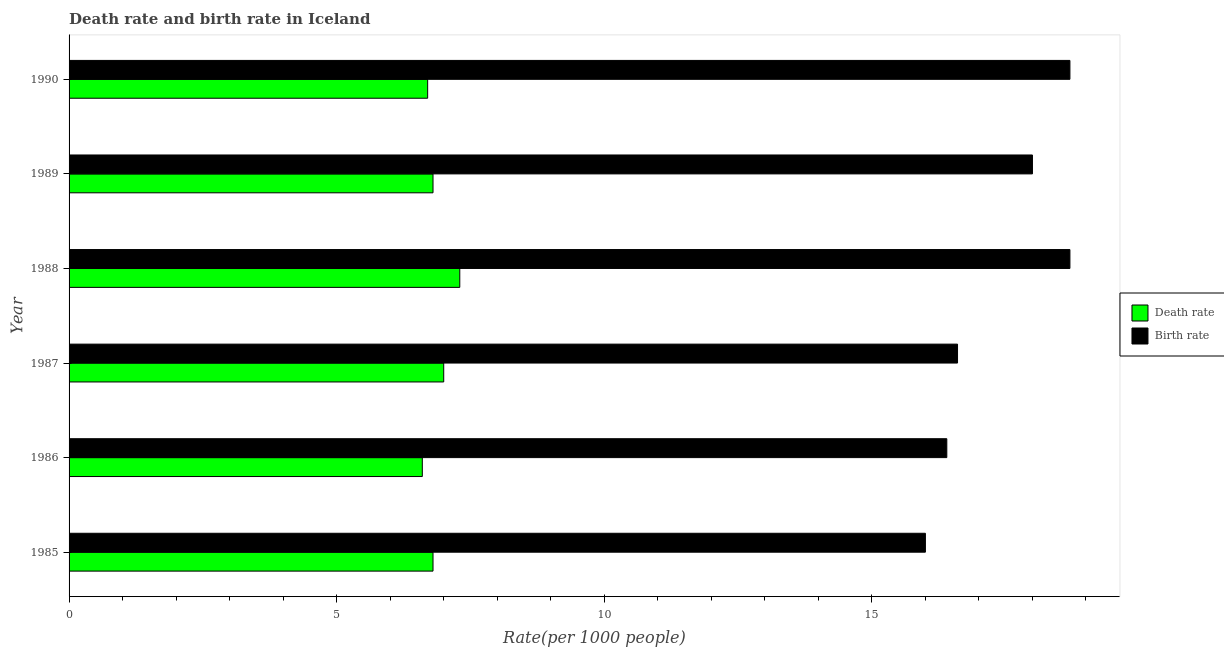How many different coloured bars are there?
Provide a short and direct response. 2. How many groups of bars are there?
Your response must be concise. 6. Are the number of bars per tick equal to the number of legend labels?
Provide a succinct answer. Yes. Are the number of bars on each tick of the Y-axis equal?
Offer a very short reply. Yes. How many bars are there on the 5th tick from the bottom?
Give a very brief answer. 2. What is the label of the 1st group of bars from the top?
Offer a very short reply. 1990. In how many cases, is the number of bars for a given year not equal to the number of legend labels?
Ensure brevity in your answer.  0. What is the death rate in 1987?
Provide a short and direct response. 7. In which year was the death rate maximum?
Offer a terse response. 1988. What is the total birth rate in the graph?
Your response must be concise. 104.4. What is the difference between the birth rate in 1989 and that in 1990?
Provide a succinct answer. -0.7. What is the average birth rate per year?
Give a very brief answer. 17.4. In how many years, is the birth rate greater than 4 ?
Make the answer very short. 6. What is the ratio of the death rate in 1985 to that in 1989?
Your answer should be very brief. 1. Is the death rate in 1987 less than that in 1989?
Give a very brief answer. No. What is the difference between the highest and the lowest birth rate?
Provide a succinct answer. 2.7. In how many years, is the birth rate greater than the average birth rate taken over all years?
Offer a very short reply. 3. What does the 1st bar from the top in 1985 represents?
Make the answer very short. Birth rate. What does the 1st bar from the bottom in 1986 represents?
Give a very brief answer. Death rate. How many bars are there?
Keep it short and to the point. 12. Are all the bars in the graph horizontal?
Offer a terse response. Yes. What is the difference between two consecutive major ticks on the X-axis?
Keep it short and to the point. 5. Does the graph contain any zero values?
Offer a very short reply. No. Does the graph contain grids?
Make the answer very short. No. Where does the legend appear in the graph?
Make the answer very short. Center right. How many legend labels are there?
Offer a terse response. 2. How are the legend labels stacked?
Provide a short and direct response. Vertical. What is the title of the graph?
Provide a short and direct response. Death rate and birth rate in Iceland. What is the label or title of the X-axis?
Your response must be concise. Rate(per 1000 people). What is the label or title of the Y-axis?
Provide a short and direct response. Year. What is the Rate(per 1000 people) of Death rate in 1985?
Give a very brief answer. 6.8. What is the Rate(per 1000 people) of Death rate in 1986?
Your answer should be very brief. 6.6. What is the Rate(per 1000 people) of Birth rate in 1986?
Offer a very short reply. 16.4. What is the Rate(per 1000 people) in Death rate in 1987?
Your answer should be very brief. 7. What is the Rate(per 1000 people) in Birth rate in 1987?
Offer a very short reply. 16.6. What is the Rate(per 1000 people) of Death rate in 1989?
Ensure brevity in your answer.  6.8. What is the Rate(per 1000 people) of Birth rate in 1990?
Provide a short and direct response. 18.7. Across all years, what is the minimum Rate(per 1000 people) in Death rate?
Make the answer very short. 6.6. What is the total Rate(per 1000 people) of Death rate in the graph?
Provide a succinct answer. 41.2. What is the total Rate(per 1000 people) in Birth rate in the graph?
Your response must be concise. 104.4. What is the difference between the Rate(per 1000 people) of Death rate in 1985 and that in 1986?
Offer a terse response. 0.2. What is the difference between the Rate(per 1000 people) of Birth rate in 1985 and that in 1986?
Give a very brief answer. -0.4. What is the difference between the Rate(per 1000 people) in Death rate in 1985 and that in 1987?
Provide a succinct answer. -0.2. What is the difference between the Rate(per 1000 people) in Death rate in 1985 and that in 1988?
Provide a succinct answer. -0.5. What is the difference between the Rate(per 1000 people) in Death rate in 1985 and that in 1989?
Keep it short and to the point. 0. What is the difference between the Rate(per 1000 people) of Birth rate in 1985 and that in 1989?
Provide a succinct answer. -2. What is the difference between the Rate(per 1000 people) of Death rate in 1985 and that in 1990?
Offer a very short reply. 0.1. What is the difference between the Rate(per 1000 people) of Birth rate in 1985 and that in 1990?
Your response must be concise. -2.7. What is the difference between the Rate(per 1000 people) in Death rate in 1986 and that in 1987?
Offer a very short reply. -0.4. What is the difference between the Rate(per 1000 people) of Birth rate in 1986 and that in 1987?
Give a very brief answer. -0.2. What is the difference between the Rate(per 1000 people) of Birth rate in 1986 and that in 1988?
Give a very brief answer. -2.3. What is the difference between the Rate(per 1000 people) in Death rate in 1986 and that in 1989?
Offer a very short reply. -0.2. What is the difference between the Rate(per 1000 people) in Death rate in 1986 and that in 1990?
Provide a succinct answer. -0.1. What is the difference between the Rate(per 1000 people) of Birth rate in 1986 and that in 1990?
Your answer should be compact. -2.3. What is the difference between the Rate(per 1000 people) of Death rate in 1987 and that in 1989?
Ensure brevity in your answer.  0.2. What is the difference between the Rate(per 1000 people) of Death rate in 1987 and that in 1990?
Provide a succinct answer. 0.3. What is the difference between the Rate(per 1000 people) of Death rate in 1988 and that in 1989?
Provide a succinct answer. 0.5. What is the difference between the Rate(per 1000 people) in Death rate in 1989 and that in 1990?
Your answer should be compact. 0.1. What is the difference between the Rate(per 1000 people) of Death rate in 1985 and the Rate(per 1000 people) of Birth rate in 1986?
Make the answer very short. -9.6. What is the difference between the Rate(per 1000 people) of Death rate in 1985 and the Rate(per 1000 people) of Birth rate in 1988?
Offer a very short reply. -11.9. What is the difference between the Rate(per 1000 people) in Death rate in 1985 and the Rate(per 1000 people) in Birth rate in 1990?
Ensure brevity in your answer.  -11.9. What is the difference between the Rate(per 1000 people) in Death rate in 1986 and the Rate(per 1000 people) in Birth rate in 1987?
Provide a short and direct response. -10. What is the difference between the Rate(per 1000 people) in Death rate in 1986 and the Rate(per 1000 people) in Birth rate in 1988?
Make the answer very short. -12.1. What is the difference between the Rate(per 1000 people) of Death rate in 1986 and the Rate(per 1000 people) of Birth rate in 1989?
Your response must be concise. -11.4. What is the difference between the Rate(per 1000 people) in Death rate in 1986 and the Rate(per 1000 people) in Birth rate in 1990?
Provide a short and direct response. -12.1. What is the difference between the Rate(per 1000 people) of Death rate in 1987 and the Rate(per 1000 people) of Birth rate in 1990?
Your response must be concise. -11.7. What is the difference between the Rate(per 1000 people) of Death rate in 1988 and the Rate(per 1000 people) of Birth rate in 1989?
Your answer should be very brief. -10.7. What is the difference between the Rate(per 1000 people) in Death rate in 1988 and the Rate(per 1000 people) in Birth rate in 1990?
Offer a terse response. -11.4. What is the average Rate(per 1000 people) of Death rate per year?
Offer a terse response. 6.87. In the year 1987, what is the difference between the Rate(per 1000 people) in Death rate and Rate(per 1000 people) in Birth rate?
Offer a terse response. -9.6. In the year 1988, what is the difference between the Rate(per 1000 people) in Death rate and Rate(per 1000 people) in Birth rate?
Give a very brief answer. -11.4. In the year 1989, what is the difference between the Rate(per 1000 people) of Death rate and Rate(per 1000 people) of Birth rate?
Your response must be concise. -11.2. In the year 1990, what is the difference between the Rate(per 1000 people) of Death rate and Rate(per 1000 people) of Birth rate?
Give a very brief answer. -12. What is the ratio of the Rate(per 1000 people) in Death rate in 1985 to that in 1986?
Your answer should be compact. 1.03. What is the ratio of the Rate(per 1000 people) in Birth rate in 1985 to that in 1986?
Provide a succinct answer. 0.98. What is the ratio of the Rate(per 1000 people) of Death rate in 1985 to that in 1987?
Offer a very short reply. 0.97. What is the ratio of the Rate(per 1000 people) of Birth rate in 1985 to that in 1987?
Your answer should be very brief. 0.96. What is the ratio of the Rate(per 1000 people) in Death rate in 1985 to that in 1988?
Offer a very short reply. 0.93. What is the ratio of the Rate(per 1000 people) in Birth rate in 1985 to that in 1988?
Provide a short and direct response. 0.86. What is the ratio of the Rate(per 1000 people) in Death rate in 1985 to that in 1989?
Keep it short and to the point. 1. What is the ratio of the Rate(per 1000 people) in Death rate in 1985 to that in 1990?
Make the answer very short. 1.01. What is the ratio of the Rate(per 1000 people) in Birth rate in 1985 to that in 1990?
Provide a succinct answer. 0.86. What is the ratio of the Rate(per 1000 people) in Death rate in 1986 to that in 1987?
Offer a very short reply. 0.94. What is the ratio of the Rate(per 1000 people) in Death rate in 1986 to that in 1988?
Your answer should be compact. 0.9. What is the ratio of the Rate(per 1000 people) in Birth rate in 1986 to that in 1988?
Your answer should be compact. 0.88. What is the ratio of the Rate(per 1000 people) in Death rate in 1986 to that in 1989?
Offer a terse response. 0.97. What is the ratio of the Rate(per 1000 people) of Birth rate in 1986 to that in 1989?
Ensure brevity in your answer.  0.91. What is the ratio of the Rate(per 1000 people) of Death rate in 1986 to that in 1990?
Make the answer very short. 0.99. What is the ratio of the Rate(per 1000 people) of Birth rate in 1986 to that in 1990?
Ensure brevity in your answer.  0.88. What is the ratio of the Rate(per 1000 people) of Death rate in 1987 to that in 1988?
Provide a short and direct response. 0.96. What is the ratio of the Rate(per 1000 people) in Birth rate in 1987 to that in 1988?
Make the answer very short. 0.89. What is the ratio of the Rate(per 1000 people) of Death rate in 1987 to that in 1989?
Your answer should be very brief. 1.03. What is the ratio of the Rate(per 1000 people) of Birth rate in 1987 to that in 1989?
Provide a succinct answer. 0.92. What is the ratio of the Rate(per 1000 people) of Death rate in 1987 to that in 1990?
Your answer should be compact. 1.04. What is the ratio of the Rate(per 1000 people) in Birth rate in 1987 to that in 1990?
Offer a very short reply. 0.89. What is the ratio of the Rate(per 1000 people) of Death rate in 1988 to that in 1989?
Give a very brief answer. 1.07. What is the ratio of the Rate(per 1000 people) of Birth rate in 1988 to that in 1989?
Ensure brevity in your answer.  1.04. What is the ratio of the Rate(per 1000 people) in Death rate in 1988 to that in 1990?
Offer a terse response. 1.09. What is the ratio of the Rate(per 1000 people) in Death rate in 1989 to that in 1990?
Give a very brief answer. 1.01. What is the ratio of the Rate(per 1000 people) of Birth rate in 1989 to that in 1990?
Your answer should be compact. 0.96. What is the difference between the highest and the second highest Rate(per 1000 people) in Death rate?
Make the answer very short. 0.3. What is the difference between the highest and the second highest Rate(per 1000 people) in Birth rate?
Keep it short and to the point. 0. 